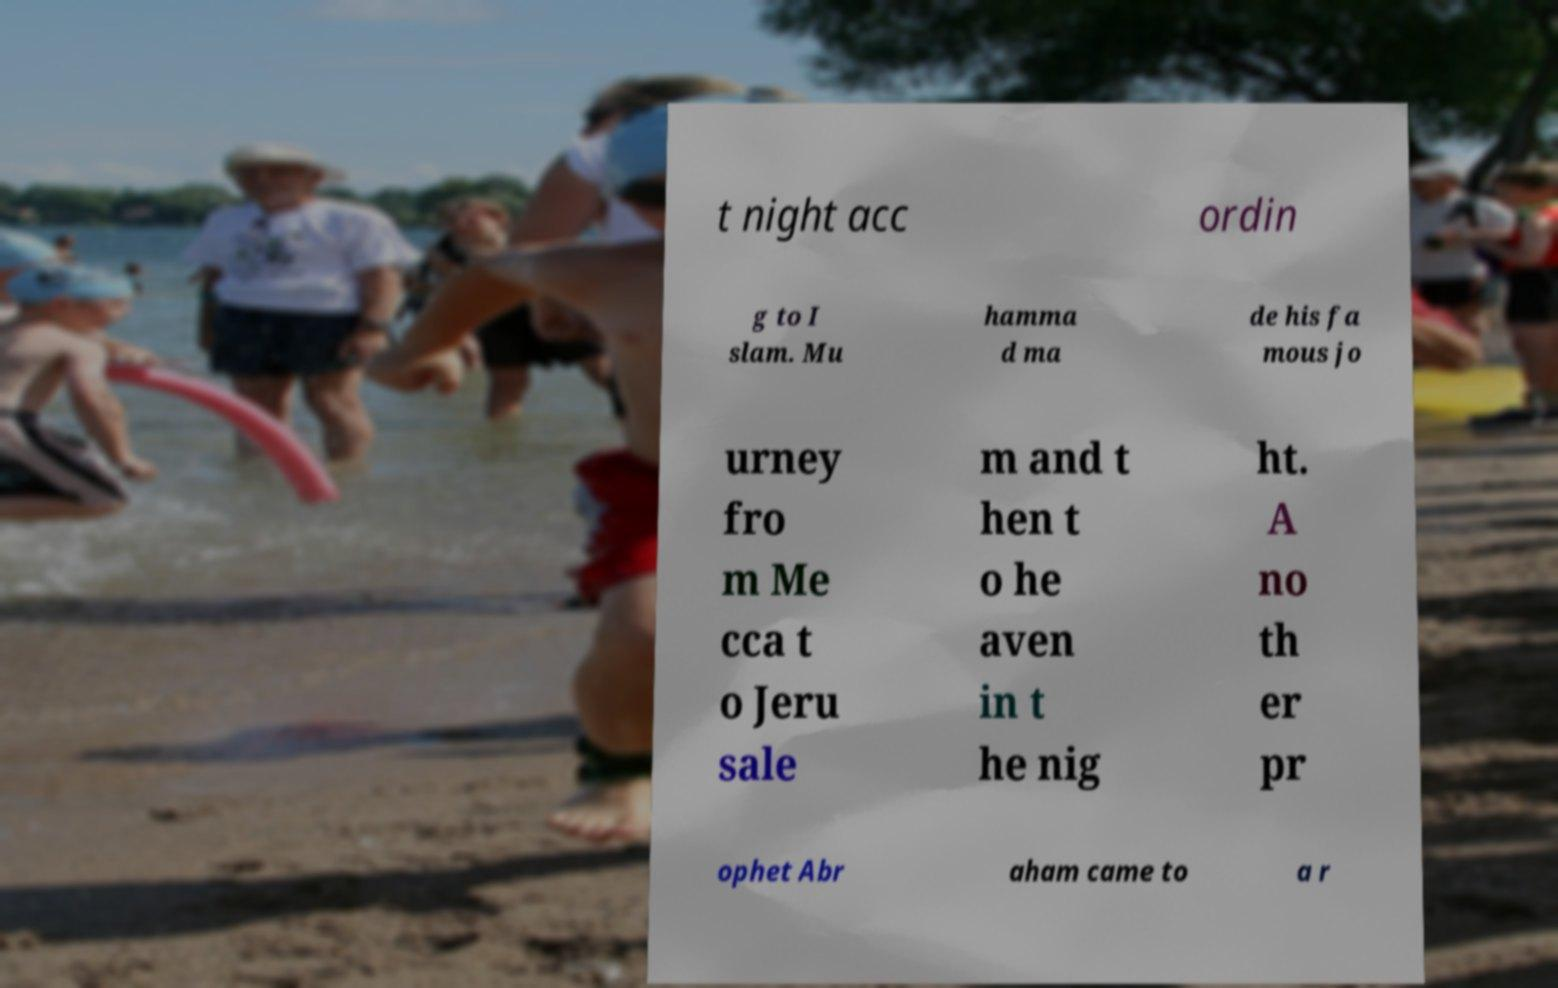Can you accurately transcribe the text from the provided image for me? t night acc ordin g to I slam. Mu hamma d ma de his fa mous jo urney fro m Me cca t o Jeru sale m and t hen t o he aven in t he nig ht. A no th er pr ophet Abr aham came to a r 